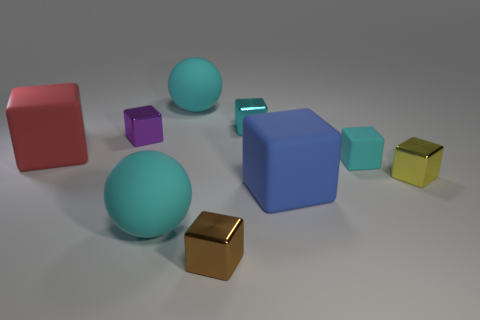Subtract all red blocks. How many blocks are left? 6 Subtract all brown cylinders. How many cyan cubes are left? 2 Subtract all brown cubes. How many cubes are left? 6 Subtract 3 blocks. How many blocks are left? 4 Add 1 small blue metallic things. How many objects exist? 10 Subtract all yellow blocks. Subtract all blue spheres. How many blocks are left? 6 Subtract all spheres. How many objects are left? 7 Add 5 large red shiny things. How many large red shiny things exist? 5 Subtract 1 cyan blocks. How many objects are left? 8 Subtract all big blue shiny cylinders. Subtract all shiny things. How many objects are left? 5 